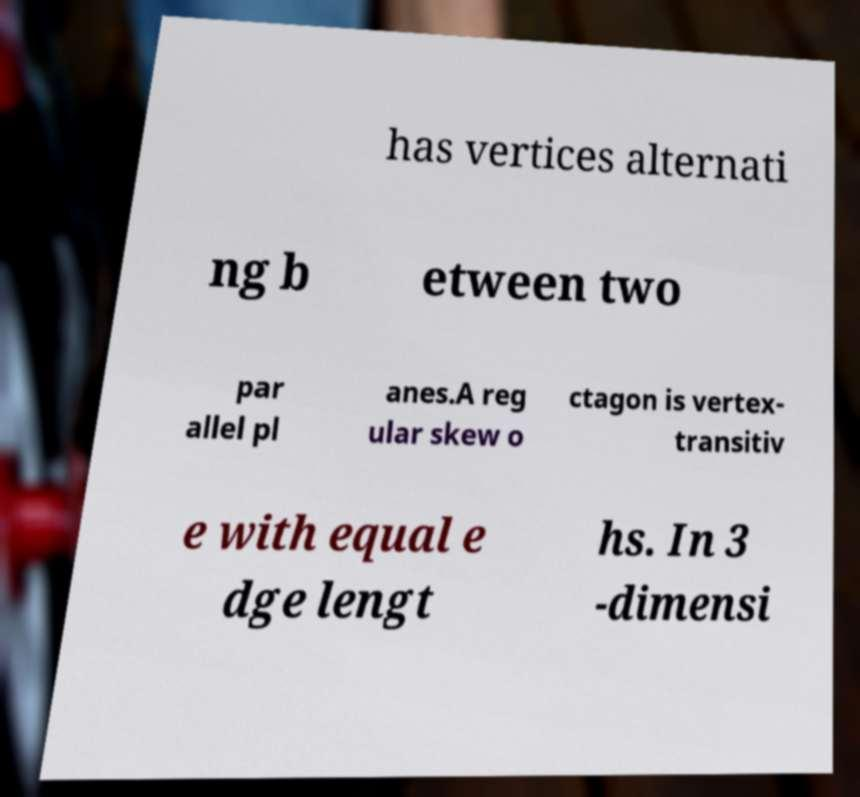There's text embedded in this image that I need extracted. Can you transcribe it verbatim? has vertices alternati ng b etween two par allel pl anes.A reg ular skew o ctagon is vertex- transitiv e with equal e dge lengt hs. In 3 -dimensi 